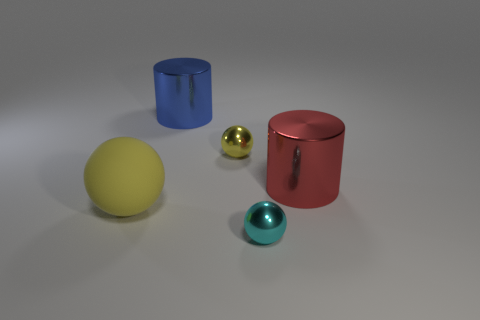Is the color of the big cylinder that is in front of the small yellow metallic sphere the same as the big rubber thing?
Keep it short and to the point. No. There is a big thing that is behind the metal cylinder in front of the big blue cylinder; what shape is it?
Make the answer very short. Cylinder. Are there any rubber things of the same size as the red shiny object?
Ensure brevity in your answer.  Yes. Is the number of big yellow rubber objects less than the number of big objects?
Give a very brief answer. Yes. What shape is the yellow thing that is on the left side of the tiny metal thing that is behind the metal sphere in front of the big yellow thing?
Ensure brevity in your answer.  Sphere. What number of objects are blue metallic objects right of the large yellow ball or shiny cylinders behind the red cylinder?
Keep it short and to the point. 1. There is a big red thing; are there any big blue metallic cylinders in front of it?
Your answer should be compact. No. How many objects are small metallic objects on the left side of the cyan object or small blue balls?
Make the answer very short. 1. How many red objects are either big metal cylinders or big objects?
Your answer should be very brief. 1. How many other objects are the same color as the matte ball?
Your answer should be compact. 1. 